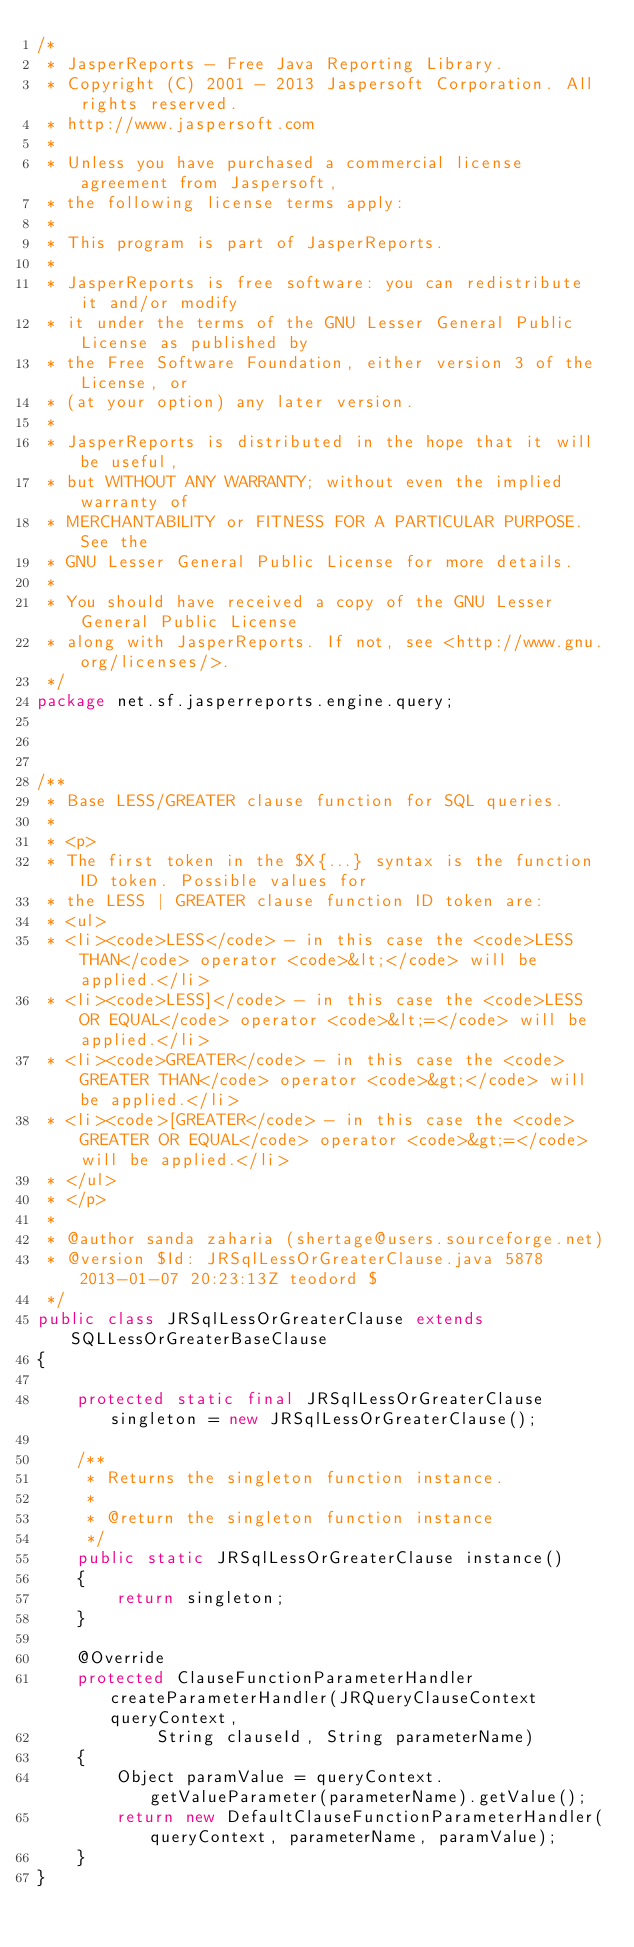Convert code to text. <code><loc_0><loc_0><loc_500><loc_500><_Java_>/*
 * JasperReports - Free Java Reporting Library.
 * Copyright (C) 2001 - 2013 Jaspersoft Corporation. All rights reserved.
 * http://www.jaspersoft.com
 *
 * Unless you have purchased a commercial license agreement from Jaspersoft,
 * the following license terms apply:
 *
 * This program is part of JasperReports.
 *
 * JasperReports is free software: you can redistribute it and/or modify
 * it under the terms of the GNU Lesser General Public License as published by
 * the Free Software Foundation, either version 3 of the License, or
 * (at your option) any later version.
 *
 * JasperReports is distributed in the hope that it will be useful,
 * but WITHOUT ANY WARRANTY; without even the implied warranty of
 * MERCHANTABILITY or FITNESS FOR A PARTICULAR PURPOSE. See the
 * GNU Lesser General Public License for more details.
 *
 * You should have received a copy of the GNU Lesser General Public License
 * along with JasperReports. If not, see <http://www.gnu.org/licenses/>.
 */
package net.sf.jasperreports.engine.query;



/**
 * Base LESS/GREATER clause function for SQL queries.
 * 
 * <p>
 * The first token in the $X{...} syntax is the function ID token. Possible values for 
 * the LESS | GREATER clause function ID token are:
 * <ul>
 * <li><code>LESS</code> - in this case the <code>LESS THAN</code> operator <code>&lt;</code> will be applied.</li>
 * <li><code>LESS]</code> - in this case the <code>LESS OR EQUAL</code> operator <code>&lt;=</code> will be applied.</li>
 * <li><code>GREATER</code> - in this case the <code>GREATER THAN</code> operator <code>&gt;</code> will be applied.</li>
 * <li><code>[GREATER</code> - in this case the <code>GREATER OR EQUAL</code> operator <code>&gt;=</code> will be applied.</li>
 * </ul>
 * </p> 
 * 
 * @author sanda zaharia (shertage@users.sourceforge.net)
 * @version $Id: JRSqlLessOrGreaterClause.java 5878 2013-01-07 20:23:13Z teodord $
 */
public class JRSqlLessOrGreaterClause extends SQLLessOrGreaterBaseClause
{

	protected static final JRSqlLessOrGreaterClause singleton = new JRSqlLessOrGreaterClause();
	
	/**
	 * Returns the singleton function instance.
	 * 
	 * @return the singleton function instance
	 */
	public static JRSqlLessOrGreaterClause instance()
	{
		return singleton;
	}

	@Override
	protected ClauseFunctionParameterHandler createParameterHandler(JRQueryClauseContext queryContext, 
			String clauseId, String parameterName)
	{
		Object paramValue = queryContext.getValueParameter(parameterName).getValue();
		return new DefaultClauseFunctionParameterHandler(queryContext, parameterName, paramValue);
	}
}
</code> 